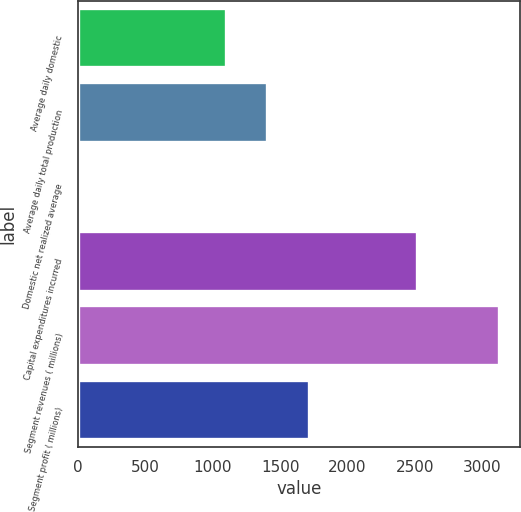Convert chart. <chart><loc_0><loc_0><loc_500><loc_500><bar_chart><fcel>Average daily domestic<fcel>Average daily total production<fcel>Domestic net realized average<fcel>Capital expenditures incurred<fcel>Segment revenues ( millions)<fcel>Segment profit ( millions)<nl><fcel>1094<fcel>1405.45<fcel>6.48<fcel>2519<fcel>3121<fcel>1716.9<nl></chart> 